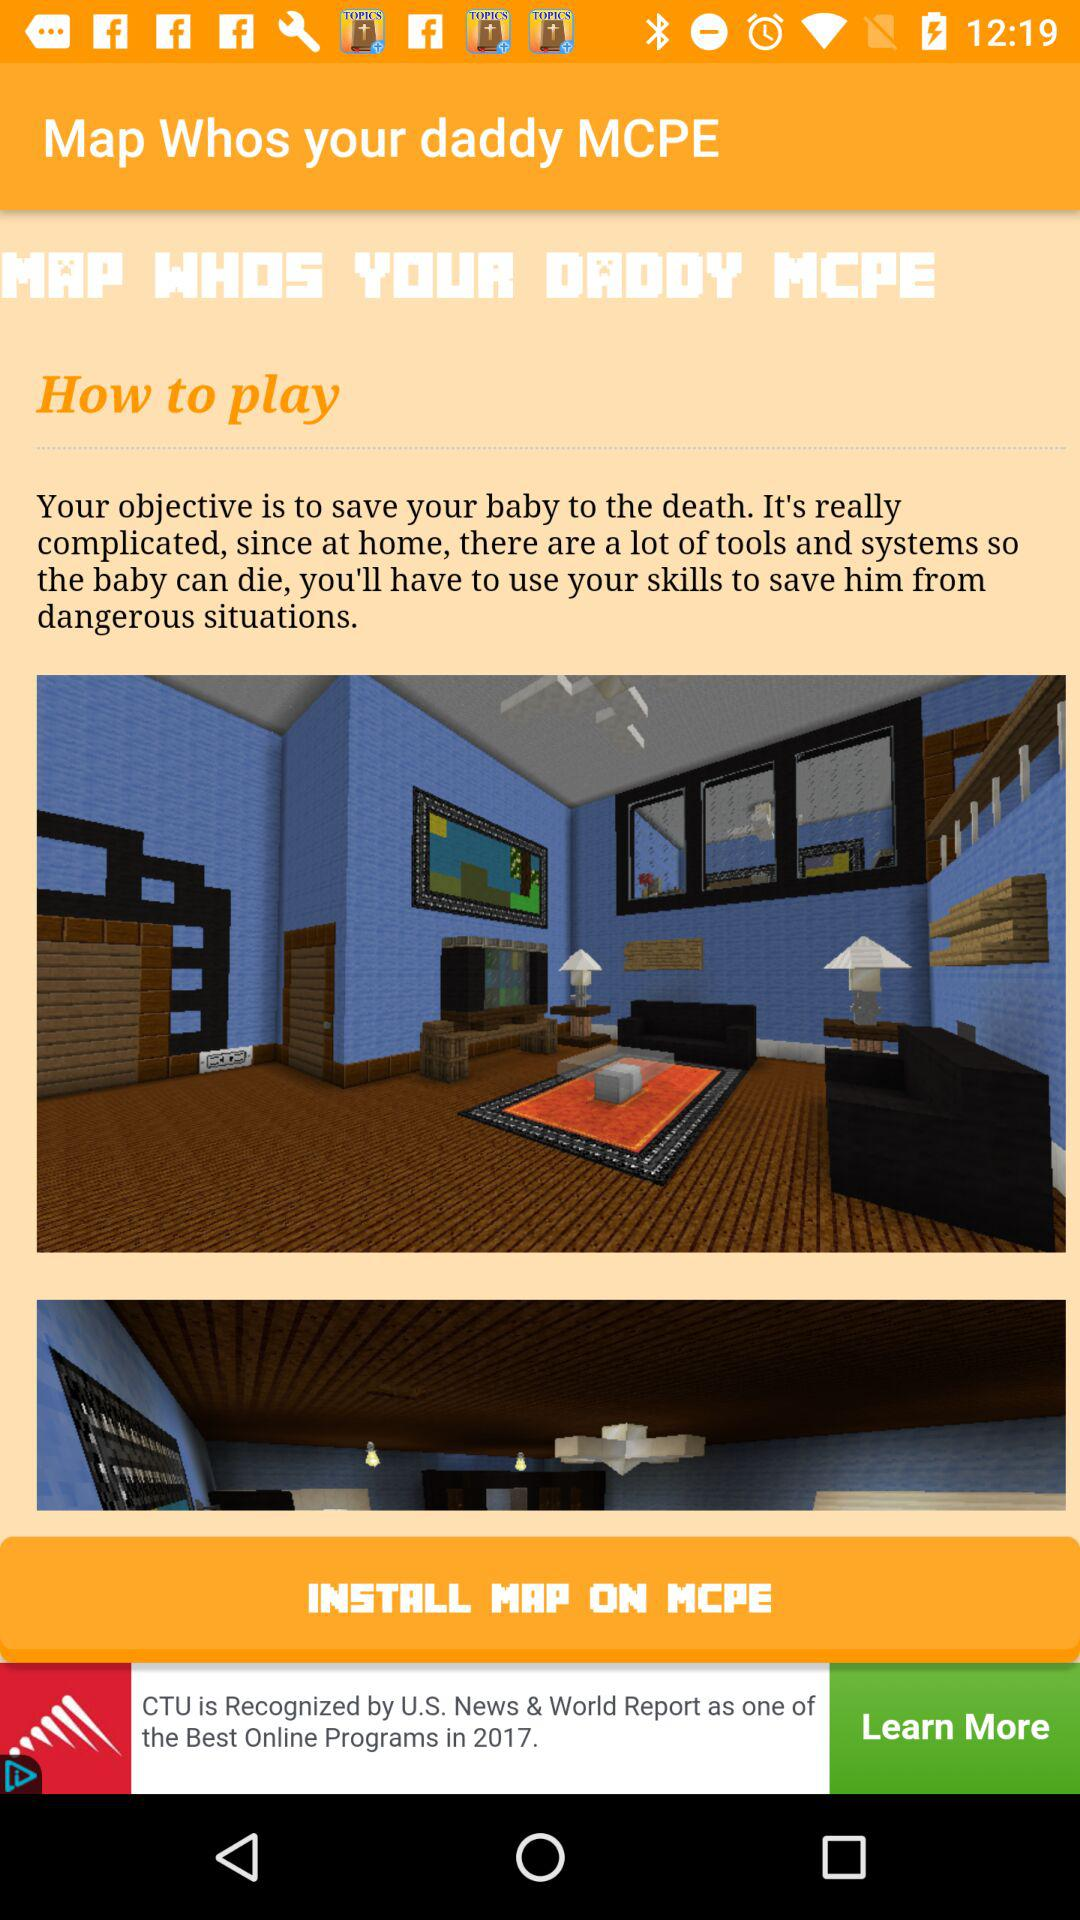What is the name of the application? The name of the application is "Map Whos your daddy MCPE". 